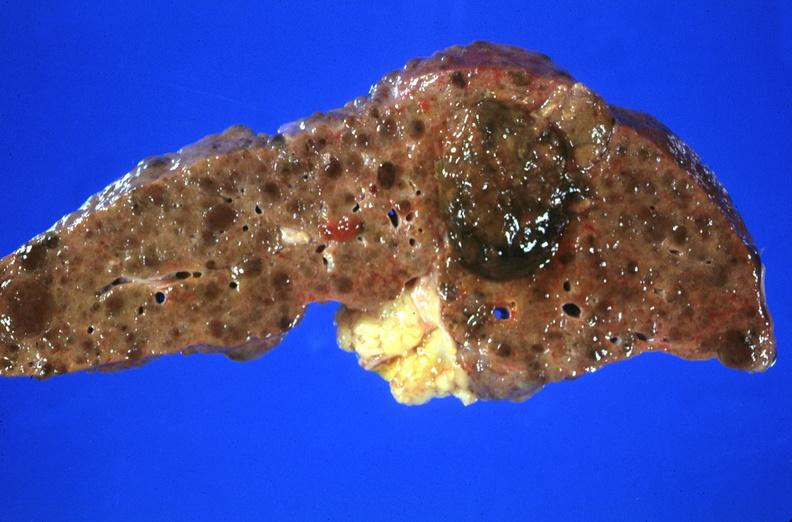s liver present?
Answer the question using a single word or phrase. Yes 